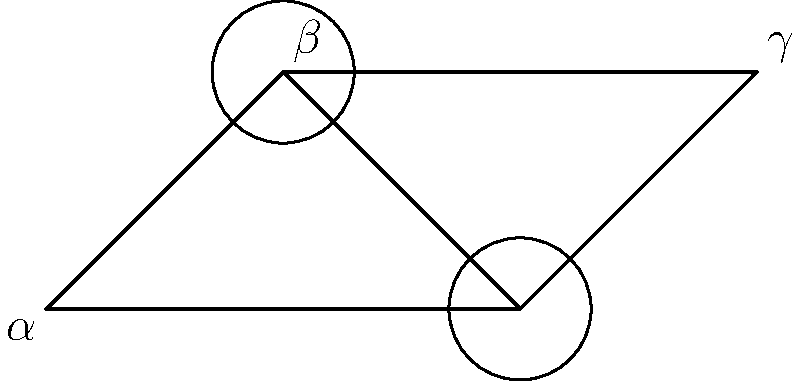In this lock mechanism illustration, which pair of angles are congruent? Explain your reasoning based on the properties of triangles and parallel lines. To determine the congruent angles in this lock mechanism, let's follow these steps:

1. Observe that we have two triangles: ABC and BCD.

2. Notice that AC and BD appear to be parallel lines, as they don't intersect within the diagram.

3. When a line intersects two parallel lines, corresponding angles are congruent. In this case, $\angle BAC$ (labeled $\alpha$) and $\angle BCD$ (labeled $\gamma$) are corresponding angles.

4. In triangle ABC, $\angle ABC$ is an exterior angle. An exterior angle of a triangle is equal to the sum of the two non-adjacent interior angles. Therefore:
   $\angle ABC = \angle BAC + \angle BCA$

5. Similarly, in triangle BCD, $\angle BCD$ is an exterior angle:
   $\angle BCD = \angle CBD + \angle BDC$

6. Since we established that $\angle BAC$ (α) and $\angle BCD$ (γ) are congruent, and they are also equal to the sum of two angles in their respective triangles, we can conclude that the remaining angles in each triangle must be congruent.

7. Therefore, $\angle BCA$ (labeled β) and $\angle CBD$ must be congruent.

Thus, the congruent pair of angles in this lock mechanism illustration is $\angle BCA$ (β) and $\angle CBD$.
Answer: $\angle BCA$ (β) and $\angle CBD$ 